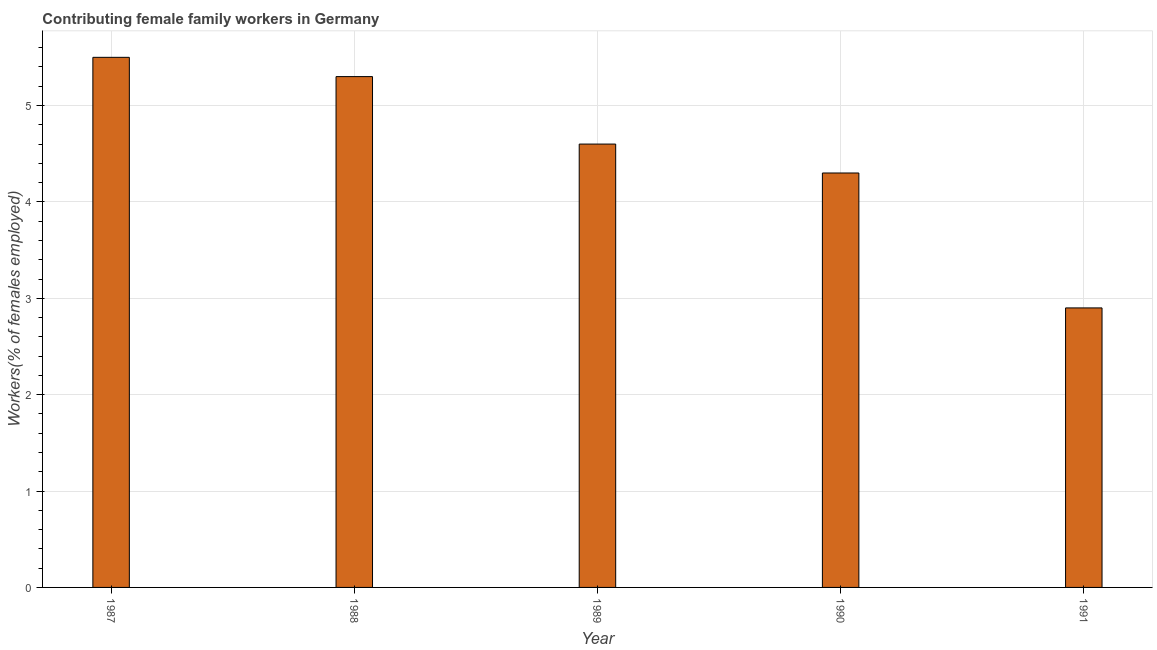Does the graph contain any zero values?
Ensure brevity in your answer.  No. Does the graph contain grids?
Offer a terse response. Yes. What is the title of the graph?
Provide a short and direct response. Contributing female family workers in Germany. What is the label or title of the X-axis?
Your response must be concise. Year. What is the label or title of the Y-axis?
Keep it short and to the point. Workers(% of females employed). What is the contributing female family workers in 1990?
Ensure brevity in your answer.  4.3. Across all years, what is the maximum contributing female family workers?
Offer a very short reply. 5.5. Across all years, what is the minimum contributing female family workers?
Offer a very short reply. 2.9. In which year was the contributing female family workers maximum?
Give a very brief answer. 1987. What is the sum of the contributing female family workers?
Your answer should be compact. 22.6. What is the difference between the contributing female family workers in 1990 and 1991?
Your response must be concise. 1.4. What is the average contributing female family workers per year?
Ensure brevity in your answer.  4.52. What is the median contributing female family workers?
Ensure brevity in your answer.  4.6. In how many years, is the contributing female family workers greater than 5.4 %?
Your response must be concise. 1. What is the ratio of the contributing female family workers in 1987 to that in 1988?
Ensure brevity in your answer.  1.04. Is the contributing female family workers in 1988 less than that in 1991?
Your answer should be compact. No. What is the difference between the highest and the second highest contributing female family workers?
Your answer should be very brief. 0.2. What is the difference between the highest and the lowest contributing female family workers?
Keep it short and to the point. 2.6. In how many years, is the contributing female family workers greater than the average contributing female family workers taken over all years?
Your answer should be compact. 3. How many bars are there?
Provide a succinct answer. 5. Are all the bars in the graph horizontal?
Your answer should be compact. No. How many years are there in the graph?
Ensure brevity in your answer.  5. What is the difference between two consecutive major ticks on the Y-axis?
Your response must be concise. 1. Are the values on the major ticks of Y-axis written in scientific E-notation?
Give a very brief answer. No. What is the Workers(% of females employed) of 1987?
Provide a short and direct response. 5.5. What is the Workers(% of females employed) in 1988?
Keep it short and to the point. 5.3. What is the Workers(% of females employed) in 1989?
Your answer should be very brief. 4.6. What is the Workers(% of females employed) in 1990?
Keep it short and to the point. 4.3. What is the Workers(% of females employed) in 1991?
Your answer should be compact. 2.9. What is the difference between the Workers(% of females employed) in 1987 and 1989?
Offer a terse response. 0.9. What is the difference between the Workers(% of females employed) in 1987 and 1991?
Offer a very short reply. 2.6. What is the difference between the Workers(% of females employed) in 1989 and 1991?
Keep it short and to the point. 1.7. What is the difference between the Workers(% of females employed) in 1990 and 1991?
Provide a short and direct response. 1.4. What is the ratio of the Workers(% of females employed) in 1987 to that in 1988?
Make the answer very short. 1.04. What is the ratio of the Workers(% of females employed) in 1987 to that in 1989?
Your response must be concise. 1.2. What is the ratio of the Workers(% of females employed) in 1987 to that in 1990?
Provide a short and direct response. 1.28. What is the ratio of the Workers(% of females employed) in 1987 to that in 1991?
Offer a very short reply. 1.9. What is the ratio of the Workers(% of females employed) in 1988 to that in 1989?
Give a very brief answer. 1.15. What is the ratio of the Workers(% of females employed) in 1988 to that in 1990?
Offer a terse response. 1.23. What is the ratio of the Workers(% of females employed) in 1988 to that in 1991?
Give a very brief answer. 1.83. What is the ratio of the Workers(% of females employed) in 1989 to that in 1990?
Offer a terse response. 1.07. What is the ratio of the Workers(% of females employed) in 1989 to that in 1991?
Give a very brief answer. 1.59. What is the ratio of the Workers(% of females employed) in 1990 to that in 1991?
Provide a succinct answer. 1.48. 